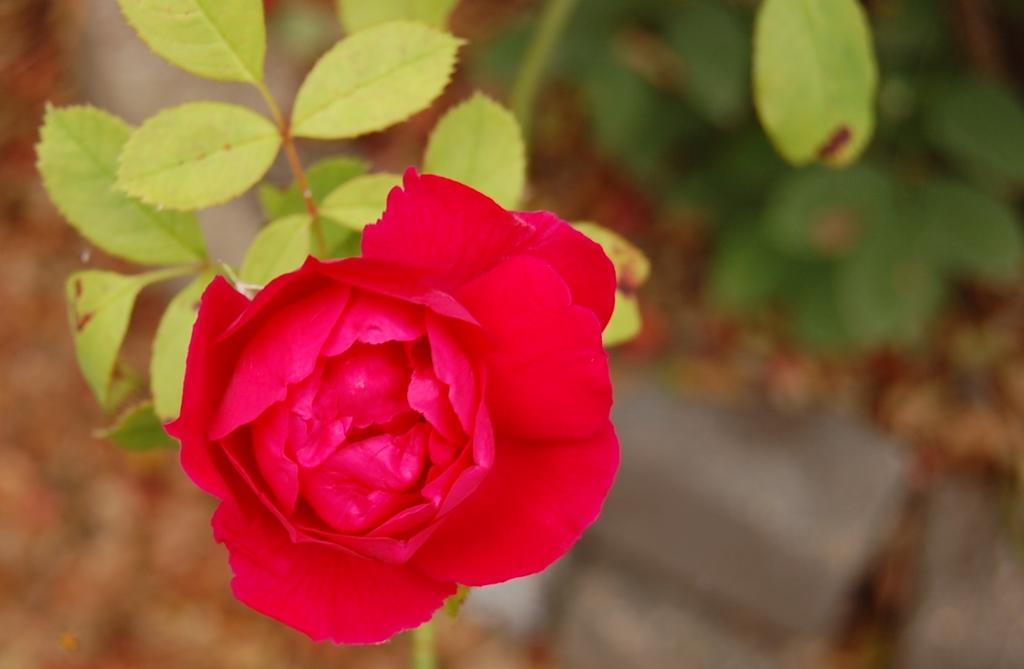What type of flower is in the image? There is a rose flower in the image. Where is the rose flower located? The rose flower is on a plant. Are there any other plants in the image? Yes, there is another plant in the image. What is the location of the other plant? The other plant is on the land. How is the basketball used in the image? There is no basketball present in the image. What rhythm is being played in the image? There is no music or rhythm present in the image. 